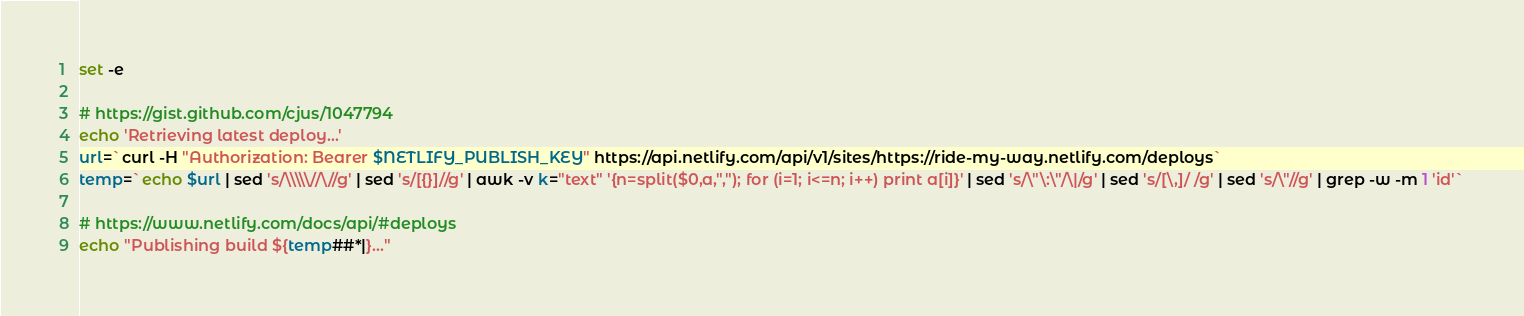<code> <loc_0><loc_0><loc_500><loc_500><_Bash_>set -e

# https://gist.github.com/cjus/1047794
echo 'Retrieving latest deploy...'
url=`curl -H "Authorization: Bearer $NETLIFY_PUBLISH_KEY" https://api.netlify.com/api/v1/sites/https://ride-my-way.netlify.com/deploys`
temp=`echo $url | sed 's/\\\\\//\//g' | sed 's/[{}]//g' | awk -v k="text" '{n=split($0,a,","); for (i=1; i<=n; i++) print a[i]}' | sed 's/\"\:\"/\|/g' | sed 's/[\,]/ /g' | sed 's/\"//g' | grep -w -m 1 'id'`

# https://www.netlify.com/docs/api/#deploys
echo "Publishing build ${temp##*|}..."</code> 